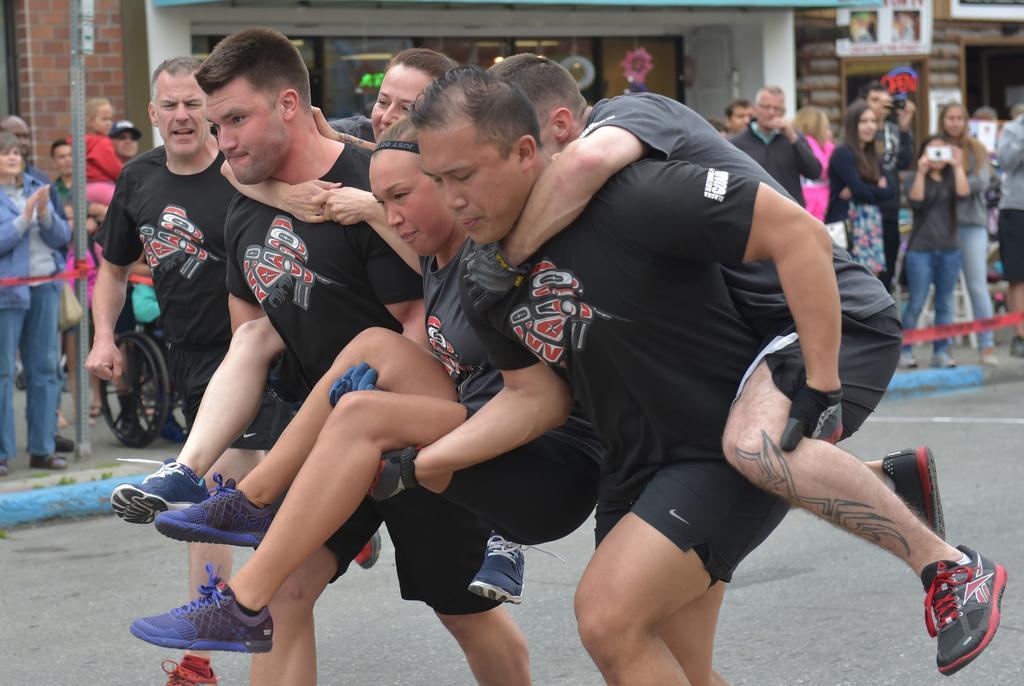Could you give a brief overview of what you see in this image? There are two men carrying other three persons on them and running on the road. In the background there are few persons,caution tape,poles,wall,glass doors,objects and hoardings. 